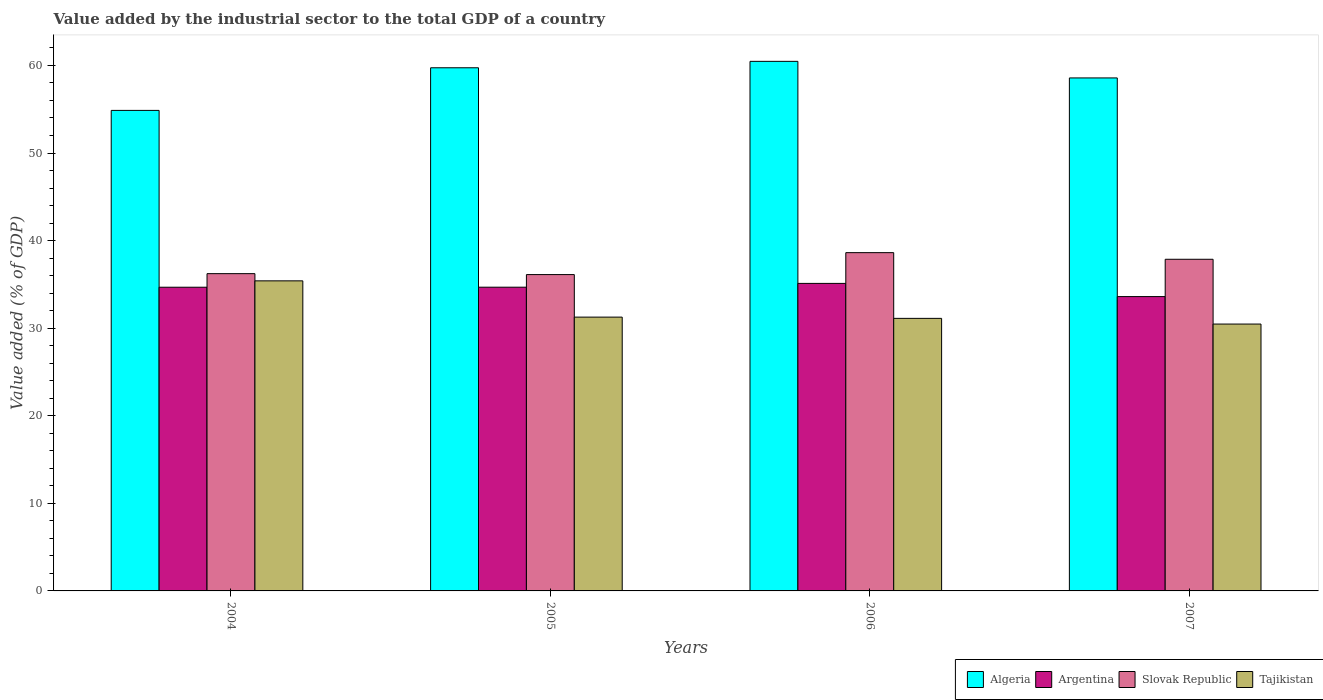How many different coloured bars are there?
Offer a terse response. 4. Are the number of bars per tick equal to the number of legend labels?
Provide a succinct answer. Yes. What is the label of the 1st group of bars from the left?
Keep it short and to the point. 2004. In how many cases, is the number of bars for a given year not equal to the number of legend labels?
Ensure brevity in your answer.  0. What is the value added by the industrial sector to the total GDP in Slovak Republic in 2007?
Provide a short and direct response. 37.87. Across all years, what is the maximum value added by the industrial sector to the total GDP in Slovak Republic?
Offer a very short reply. 38.62. Across all years, what is the minimum value added by the industrial sector to the total GDP in Tajikistan?
Provide a succinct answer. 30.47. In which year was the value added by the industrial sector to the total GDP in Algeria minimum?
Offer a terse response. 2004. What is the total value added by the industrial sector to the total GDP in Tajikistan in the graph?
Make the answer very short. 128.26. What is the difference between the value added by the industrial sector to the total GDP in Argentina in 2006 and that in 2007?
Your response must be concise. 1.51. What is the difference between the value added by the industrial sector to the total GDP in Slovak Republic in 2006 and the value added by the industrial sector to the total GDP in Algeria in 2004?
Offer a terse response. -16.24. What is the average value added by the industrial sector to the total GDP in Tajikistan per year?
Provide a short and direct response. 32.06. In the year 2004, what is the difference between the value added by the industrial sector to the total GDP in Tajikistan and value added by the industrial sector to the total GDP in Argentina?
Ensure brevity in your answer.  0.73. In how many years, is the value added by the industrial sector to the total GDP in Algeria greater than 60 %?
Give a very brief answer. 1. What is the ratio of the value added by the industrial sector to the total GDP in Slovak Republic in 2006 to that in 2007?
Make the answer very short. 1.02. Is the value added by the industrial sector to the total GDP in Argentina in 2004 less than that in 2007?
Provide a succinct answer. No. What is the difference between the highest and the second highest value added by the industrial sector to the total GDP in Slovak Republic?
Your answer should be very brief. 0.76. What is the difference between the highest and the lowest value added by the industrial sector to the total GDP in Argentina?
Keep it short and to the point. 1.51. In how many years, is the value added by the industrial sector to the total GDP in Tajikistan greater than the average value added by the industrial sector to the total GDP in Tajikistan taken over all years?
Give a very brief answer. 1. Is the sum of the value added by the industrial sector to the total GDP in Tajikistan in 2006 and 2007 greater than the maximum value added by the industrial sector to the total GDP in Algeria across all years?
Your response must be concise. Yes. What does the 3rd bar from the left in 2006 represents?
Offer a very short reply. Slovak Republic. What does the 2nd bar from the right in 2005 represents?
Make the answer very short. Slovak Republic. Is it the case that in every year, the sum of the value added by the industrial sector to the total GDP in Argentina and value added by the industrial sector to the total GDP in Algeria is greater than the value added by the industrial sector to the total GDP in Slovak Republic?
Ensure brevity in your answer.  Yes. Where does the legend appear in the graph?
Keep it short and to the point. Bottom right. How are the legend labels stacked?
Ensure brevity in your answer.  Horizontal. What is the title of the graph?
Keep it short and to the point. Value added by the industrial sector to the total GDP of a country. Does "Latin America(all income levels)" appear as one of the legend labels in the graph?
Keep it short and to the point. No. What is the label or title of the X-axis?
Keep it short and to the point. Years. What is the label or title of the Y-axis?
Your answer should be compact. Value added (% of GDP). What is the Value added (% of GDP) of Algeria in 2004?
Keep it short and to the point. 54.87. What is the Value added (% of GDP) of Argentina in 2004?
Offer a terse response. 34.68. What is the Value added (% of GDP) in Slovak Republic in 2004?
Give a very brief answer. 36.22. What is the Value added (% of GDP) in Tajikistan in 2004?
Offer a very short reply. 35.4. What is the Value added (% of GDP) of Algeria in 2005?
Offer a terse response. 59.73. What is the Value added (% of GDP) in Argentina in 2005?
Your response must be concise. 34.68. What is the Value added (% of GDP) of Slovak Republic in 2005?
Make the answer very short. 36.12. What is the Value added (% of GDP) in Tajikistan in 2005?
Make the answer very short. 31.26. What is the Value added (% of GDP) in Algeria in 2006?
Your response must be concise. 60.46. What is the Value added (% of GDP) of Argentina in 2006?
Your answer should be very brief. 35.11. What is the Value added (% of GDP) in Slovak Republic in 2006?
Your answer should be very brief. 38.62. What is the Value added (% of GDP) in Tajikistan in 2006?
Give a very brief answer. 31.12. What is the Value added (% of GDP) in Algeria in 2007?
Your response must be concise. 58.57. What is the Value added (% of GDP) in Argentina in 2007?
Your answer should be compact. 33.61. What is the Value added (% of GDP) in Slovak Republic in 2007?
Provide a succinct answer. 37.87. What is the Value added (% of GDP) in Tajikistan in 2007?
Keep it short and to the point. 30.47. Across all years, what is the maximum Value added (% of GDP) in Algeria?
Ensure brevity in your answer.  60.46. Across all years, what is the maximum Value added (% of GDP) in Argentina?
Your answer should be compact. 35.11. Across all years, what is the maximum Value added (% of GDP) of Slovak Republic?
Your answer should be compact. 38.62. Across all years, what is the maximum Value added (% of GDP) of Tajikistan?
Your response must be concise. 35.4. Across all years, what is the minimum Value added (% of GDP) of Algeria?
Give a very brief answer. 54.87. Across all years, what is the minimum Value added (% of GDP) of Argentina?
Provide a succinct answer. 33.61. Across all years, what is the minimum Value added (% of GDP) of Slovak Republic?
Provide a succinct answer. 36.12. Across all years, what is the minimum Value added (% of GDP) of Tajikistan?
Make the answer very short. 30.47. What is the total Value added (% of GDP) in Algeria in the graph?
Give a very brief answer. 233.63. What is the total Value added (% of GDP) in Argentina in the graph?
Provide a succinct answer. 138.07. What is the total Value added (% of GDP) in Slovak Republic in the graph?
Offer a very short reply. 148.83. What is the total Value added (% of GDP) in Tajikistan in the graph?
Offer a terse response. 128.26. What is the difference between the Value added (% of GDP) of Algeria in 2004 and that in 2005?
Offer a terse response. -4.87. What is the difference between the Value added (% of GDP) in Argentina in 2004 and that in 2005?
Your answer should be compact. -0. What is the difference between the Value added (% of GDP) in Slovak Republic in 2004 and that in 2005?
Ensure brevity in your answer.  0.11. What is the difference between the Value added (% of GDP) in Tajikistan in 2004 and that in 2005?
Your answer should be compact. 4.14. What is the difference between the Value added (% of GDP) of Algeria in 2004 and that in 2006?
Keep it short and to the point. -5.6. What is the difference between the Value added (% of GDP) in Argentina in 2004 and that in 2006?
Provide a short and direct response. -0.44. What is the difference between the Value added (% of GDP) of Slovak Republic in 2004 and that in 2006?
Keep it short and to the point. -2.4. What is the difference between the Value added (% of GDP) of Tajikistan in 2004 and that in 2006?
Provide a succinct answer. 4.28. What is the difference between the Value added (% of GDP) in Algeria in 2004 and that in 2007?
Make the answer very short. -3.71. What is the difference between the Value added (% of GDP) of Argentina in 2004 and that in 2007?
Make the answer very short. 1.07. What is the difference between the Value added (% of GDP) in Slovak Republic in 2004 and that in 2007?
Give a very brief answer. -1.64. What is the difference between the Value added (% of GDP) in Tajikistan in 2004 and that in 2007?
Offer a terse response. 4.93. What is the difference between the Value added (% of GDP) of Algeria in 2005 and that in 2006?
Offer a very short reply. -0.73. What is the difference between the Value added (% of GDP) of Argentina in 2005 and that in 2006?
Your answer should be compact. -0.43. What is the difference between the Value added (% of GDP) of Slovak Republic in 2005 and that in 2006?
Make the answer very short. -2.51. What is the difference between the Value added (% of GDP) of Tajikistan in 2005 and that in 2006?
Your answer should be compact. 0.14. What is the difference between the Value added (% of GDP) in Algeria in 2005 and that in 2007?
Keep it short and to the point. 1.16. What is the difference between the Value added (% of GDP) in Argentina in 2005 and that in 2007?
Ensure brevity in your answer.  1.07. What is the difference between the Value added (% of GDP) in Slovak Republic in 2005 and that in 2007?
Keep it short and to the point. -1.75. What is the difference between the Value added (% of GDP) in Tajikistan in 2005 and that in 2007?
Provide a succinct answer. 0.79. What is the difference between the Value added (% of GDP) in Algeria in 2006 and that in 2007?
Give a very brief answer. 1.89. What is the difference between the Value added (% of GDP) of Argentina in 2006 and that in 2007?
Provide a short and direct response. 1.51. What is the difference between the Value added (% of GDP) in Slovak Republic in 2006 and that in 2007?
Make the answer very short. 0.76. What is the difference between the Value added (% of GDP) in Tajikistan in 2006 and that in 2007?
Make the answer very short. 0.65. What is the difference between the Value added (% of GDP) in Algeria in 2004 and the Value added (% of GDP) in Argentina in 2005?
Ensure brevity in your answer.  20.19. What is the difference between the Value added (% of GDP) in Algeria in 2004 and the Value added (% of GDP) in Slovak Republic in 2005?
Offer a terse response. 18.75. What is the difference between the Value added (% of GDP) of Algeria in 2004 and the Value added (% of GDP) of Tajikistan in 2005?
Offer a very short reply. 23.6. What is the difference between the Value added (% of GDP) in Argentina in 2004 and the Value added (% of GDP) in Slovak Republic in 2005?
Offer a very short reply. -1.44. What is the difference between the Value added (% of GDP) in Argentina in 2004 and the Value added (% of GDP) in Tajikistan in 2005?
Offer a terse response. 3.41. What is the difference between the Value added (% of GDP) in Slovak Republic in 2004 and the Value added (% of GDP) in Tajikistan in 2005?
Your answer should be very brief. 4.96. What is the difference between the Value added (% of GDP) of Algeria in 2004 and the Value added (% of GDP) of Argentina in 2006?
Offer a terse response. 19.75. What is the difference between the Value added (% of GDP) of Algeria in 2004 and the Value added (% of GDP) of Slovak Republic in 2006?
Your response must be concise. 16.24. What is the difference between the Value added (% of GDP) in Algeria in 2004 and the Value added (% of GDP) in Tajikistan in 2006?
Give a very brief answer. 23.75. What is the difference between the Value added (% of GDP) of Argentina in 2004 and the Value added (% of GDP) of Slovak Republic in 2006?
Keep it short and to the point. -3.95. What is the difference between the Value added (% of GDP) in Argentina in 2004 and the Value added (% of GDP) in Tajikistan in 2006?
Provide a short and direct response. 3.56. What is the difference between the Value added (% of GDP) of Slovak Republic in 2004 and the Value added (% of GDP) of Tajikistan in 2006?
Ensure brevity in your answer.  5.11. What is the difference between the Value added (% of GDP) in Algeria in 2004 and the Value added (% of GDP) in Argentina in 2007?
Offer a terse response. 21.26. What is the difference between the Value added (% of GDP) in Algeria in 2004 and the Value added (% of GDP) in Slovak Republic in 2007?
Your response must be concise. 17. What is the difference between the Value added (% of GDP) of Algeria in 2004 and the Value added (% of GDP) of Tajikistan in 2007?
Your response must be concise. 24.39. What is the difference between the Value added (% of GDP) in Argentina in 2004 and the Value added (% of GDP) in Slovak Republic in 2007?
Keep it short and to the point. -3.19. What is the difference between the Value added (% of GDP) of Argentina in 2004 and the Value added (% of GDP) of Tajikistan in 2007?
Offer a very short reply. 4.2. What is the difference between the Value added (% of GDP) in Slovak Republic in 2004 and the Value added (% of GDP) in Tajikistan in 2007?
Give a very brief answer. 5.75. What is the difference between the Value added (% of GDP) of Algeria in 2005 and the Value added (% of GDP) of Argentina in 2006?
Offer a terse response. 24.62. What is the difference between the Value added (% of GDP) of Algeria in 2005 and the Value added (% of GDP) of Slovak Republic in 2006?
Provide a succinct answer. 21.11. What is the difference between the Value added (% of GDP) in Algeria in 2005 and the Value added (% of GDP) in Tajikistan in 2006?
Keep it short and to the point. 28.61. What is the difference between the Value added (% of GDP) in Argentina in 2005 and the Value added (% of GDP) in Slovak Republic in 2006?
Your answer should be very brief. -3.94. What is the difference between the Value added (% of GDP) of Argentina in 2005 and the Value added (% of GDP) of Tajikistan in 2006?
Offer a terse response. 3.56. What is the difference between the Value added (% of GDP) in Slovak Republic in 2005 and the Value added (% of GDP) in Tajikistan in 2006?
Provide a succinct answer. 5. What is the difference between the Value added (% of GDP) of Algeria in 2005 and the Value added (% of GDP) of Argentina in 2007?
Offer a very short reply. 26.13. What is the difference between the Value added (% of GDP) in Algeria in 2005 and the Value added (% of GDP) in Slovak Republic in 2007?
Your answer should be compact. 21.87. What is the difference between the Value added (% of GDP) of Algeria in 2005 and the Value added (% of GDP) of Tajikistan in 2007?
Keep it short and to the point. 29.26. What is the difference between the Value added (% of GDP) in Argentina in 2005 and the Value added (% of GDP) in Slovak Republic in 2007?
Offer a very short reply. -3.19. What is the difference between the Value added (% of GDP) in Argentina in 2005 and the Value added (% of GDP) in Tajikistan in 2007?
Your answer should be very brief. 4.21. What is the difference between the Value added (% of GDP) of Slovak Republic in 2005 and the Value added (% of GDP) of Tajikistan in 2007?
Give a very brief answer. 5.65. What is the difference between the Value added (% of GDP) in Algeria in 2006 and the Value added (% of GDP) in Argentina in 2007?
Offer a very short reply. 26.86. What is the difference between the Value added (% of GDP) of Algeria in 2006 and the Value added (% of GDP) of Slovak Republic in 2007?
Make the answer very short. 22.6. What is the difference between the Value added (% of GDP) of Algeria in 2006 and the Value added (% of GDP) of Tajikistan in 2007?
Offer a very short reply. 29.99. What is the difference between the Value added (% of GDP) of Argentina in 2006 and the Value added (% of GDP) of Slovak Republic in 2007?
Provide a short and direct response. -2.75. What is the difference between the Value added (% of GDP) of Argentina in 2006 and the Value added (% of GDP) of Tajikistan in 2007?
Your response must be concise. 4.64. What is the difference between the Value added (% of GDP) of Slovak Republic in 2006 and the Value added (% of GDP) of Tajikistan in 2007?
Offer a terse response. 8.15. What is the average Value added (% of GDP) in Algeria per year?
Your answer should be compact. 58.41. What is the average Value added (% of GDP) in Argentina per year?
Provide a short and direct response. 34.52. What is the average Value added (% of GDP) in Slovak Republic per year?
Give a very brief answer. 37.21. What is the average Value added (% of GDP) of Tajikistan per year?
Offer a terse response. 32.06. In the year 2004, what is the difference between the Value added (% of GDP) of Algeria and Value added (% of GDP) of Argentina?
Provide a short and direct response. 20.19. In the year 2004, what is the difference between the Value added (% of GDP) of Algeria and Value added (% of GDP) of Slovak Republic?
Keep it short and to the point. 18.64. In the year 2004, what is the difference between the Value added (% of GDP) in Algeria and Value added (% of GDP) in Tajikistan?
Provide a succinct answer. 19.46. In the year 2004, what is the difference between the Value added (% of GDP) in Argentina and Value added (% of GDP) in Slovak Republic?
Your response must be concise. -1.55. In the year 2004, what is the difference between the Value added (% of GDP) in Argentina and Value added (% of GDP) in Tajikistan?
Offer a terse response. -0.73. In the year 2004, what is the difference between the Value added (% of GDP) in Slovak Republic and Value added (% of GDP) in Tajikistan?
Offer a terse response. 0.82. In the year 2005, what is the difference between the Value added (% of GDP) of Algeria and Value added (% of GDP) of Argentina?
Your answer should be very brief. 25.05. In the year 2005, what is the difference between the Value added (% of GDP) of Algeria and Value added (% of GDP) of Slovak Republic?
Provide a succinct answer. 23.61. In the year 2005, what is the difference between the Value added (% of GDP) in Algeria and Value added (% of GDP) in Tajikistan?
Offer a very short reply. 28.47. In the year 2005, what is the difference between the Value added (% of GDP) of Argentina and Value added (% of GDP) of Slovak Republic?
Ensure brevity in your answer.  -1.44. In the year 2005, what is the difference between the Value added (% of GDP) in Argentina and Value added (% of GDP) in Tajikistan?
Your answer should be compact. 3.42. In the year 2005, what is the difference between the Value added (% of GDP) in Slovak Republic and Value added (% of GDP) in Tajikistan?
Your answer should be very brief. 4.86. In the year 2006, what is the difference between the Value added (% of GDP) in Algeria and Value added (% of GDP) in Argentina?
Keep it short and to the point. 25.35. In the year 2006, what is the difference between the Value added (% of GDP) in Algeria and Value added (% of GDP) in Slovak Republic?
Your answer should be compact. 21.84. In the year 2006, what is the difference between the Value added (% of GDP) in Algeria and Value added (% of GDP) in Tajikistan?
Your response must be concise. 29.34. In the year 2006, what is the difference between the Value added (% of GDP) in Argentina and Value added (% of GDP) in Slovak Republic?
Keep it short and to the point. -3.51. In the year 2006, what is the difference between the Value added (% of GDP) of Argentina and Value added (% of GDP) of Tajikistan?
Give a very brief answer. 3.99. In the year 2006, what is the difference between the Value added (% of GDP) in Slovak Republic and Value added (% of GDP) in Tajikistan?
Provide a short and direct response. 7.5. In the year 2007, what is the difference between the Value added (% of GDP) in Algeria and Value added (% of GDP) in Argentina?
Make the answer very short. 24.97. In the year 2007, what is the difference between the Value added (% of GDP) in Algeria and Value added (% of GDP) in Slovak Republic?
Your answer should be very brief. 20.71. In the year 2007, what is the difference between the Value added (% of GDP) of Algeria and Value added (% of GDP) of Tajikistan?
Offer a terse response. 28.1. In the year 2007, what is the difference between the Value added (% of GDP) of Argentina and Value added (% of GDP) of Slovak Republic?
Provide a short and direct response. -4.26. In the year 2007, what is the difference between the Value added (% of GDP) of Argentina and Value added (% of GDP) of Tajikistan?
Give a very brief answer. 3.13. In the year 2007, what is the difference between the Value added (% of GDP) in Slovak Republic and Value added (% of GDP) in Tajikistan?
Offer a very short reply. 7.39. What is the ratio of the Value added (% of GDP) in Algeria in 2004 to that in 2005?
Your answer should be very brief. 0.92. What is the ratio of the Value added (% of GDP) of Argentina in 2004 to that in 2005?
Provide a succinct answer. 1. What is the ratio of the Value added (% of GDP) in Slovak Republic in 2004 to that in 2005?
Give a very brief answer. 1. What is the ratio of the Value added (% of GDP) in Tajikistan in 2004 to that in 2005?
Provide a short and direct response. 1.13. What is the ratio of the Value added (% of GDP) of Algeria in 2004 to that in 2006?
Offer a terse response. 0.91. What is the ratio of the Value added (% of GDP) of Argentina in 2004 to that in 2006?
Provide a succinct answer. 0.99. What is the ratio of the Value added (% of GDP) in Slovak Republic in 2004 to that in 2006?
Make the answer very short. 0.94. What is the ratio of the Value added (% of GDP) of Tajikistan in 2004 to that in 2006?
Your answer should be very brief. 1.14. What is the ratio of the Value added (% of GDP) in Algeria in 2004 to that in 2007?
Provide a succinct answer. 0.94. What is the ratio of the Value added (% of GDP) of Argentina in 2004 to that in 2007?
Ensure brevity in your answer.  1.03. What is the ratio of the Value added (% of GDP) in Slovak Republic in 2004 to that in 2007?
Give a very brief answer. 0.96. What is the ratio of the Value added (% of GDP) of Tajikistan in 2004 to that in 2007?
Your answer should be very brief. 1.16. What is the ratio of the Value added (% of GDP) in Algeria in 2005 to that in 2006?
Your answer should be very brief. 0.99. What is the ratio of the Value added (% of GDP) of Argentina in 2005 to that in 2006?
Ensure brevity in your answer.  0.99. What is the ratio of the Value added (% of GDP) in Slovak Republic in 2005 to that in 2006?
Make the answer very short. 0.94. What is the ratio of the Value added (% of GDP) in Algeria in 2005 to that in 2007?
Provide a succinct answer. 1.02. What is the ratio of the Value added (% of GDP) of Argentina in 2005 to that in 2007?
Make the answer very short. 1.03. What is the ratio of the Value added (% of GDP) of Slovak Republic in 2005 to that in 2007?
Ensure brevity in your answer.  0.95. What is the ratio of the Value added (% of GDP) in Tajikistan in 2005 to that in 2007?
Your response must be concise. 1.03. What is the ratio of the Value added (% of GDP) in Algeria in 2006 to that in 2007?
Keep it short and to the point. 1.03. What is the ratio of the Value added (% of GDP) of Argentina in 2006 to that in 2007?
Ensure brevity in your answer.  1.04. What is the ratio of the Value added (% of GDP) in Slovak Republic in 2006 to that in 2007?
Your answer should be very brief. 1.02. What is the ratio of the Value added (% of GDP) in Tajikistan in 2006 to that in 2007?
Your response must be concise. 1.02. What is the difference between the highest and the second highest Value added (% of GDP) in Algeria?
Make the answer very short. 0.73. What is the difference between the highest and the second highest Value added (% of GDP) of Argentina?
Your answer should be compact. 0.43. What is the difference between the highest and the second highest Value added (% of GDP) in Slovak Republic?
Offer a terse response. 0.76. What is the difference between the highest and the second highest Value added (% of GDP) of Tajikistan?
Provide a short and direct response. 4.14. What is the difference between the highest and the lowest Value added (% of GDP) in Algeria?
Ensure brevity in your answer.  5.6. What is the difference between the highest and the lowest Value added (% of GDP) in Argentina?
Offer a very short reply. 1.51. What is the difference between the highest and the lowest Value added (% of GDP) of Slovak Republic?
Provide a short and direct response. 2.51. What is the difference between the highest and the lowest Value added (% of GDP) of Tajikistan?
Give a very brief answer. 4.93. 